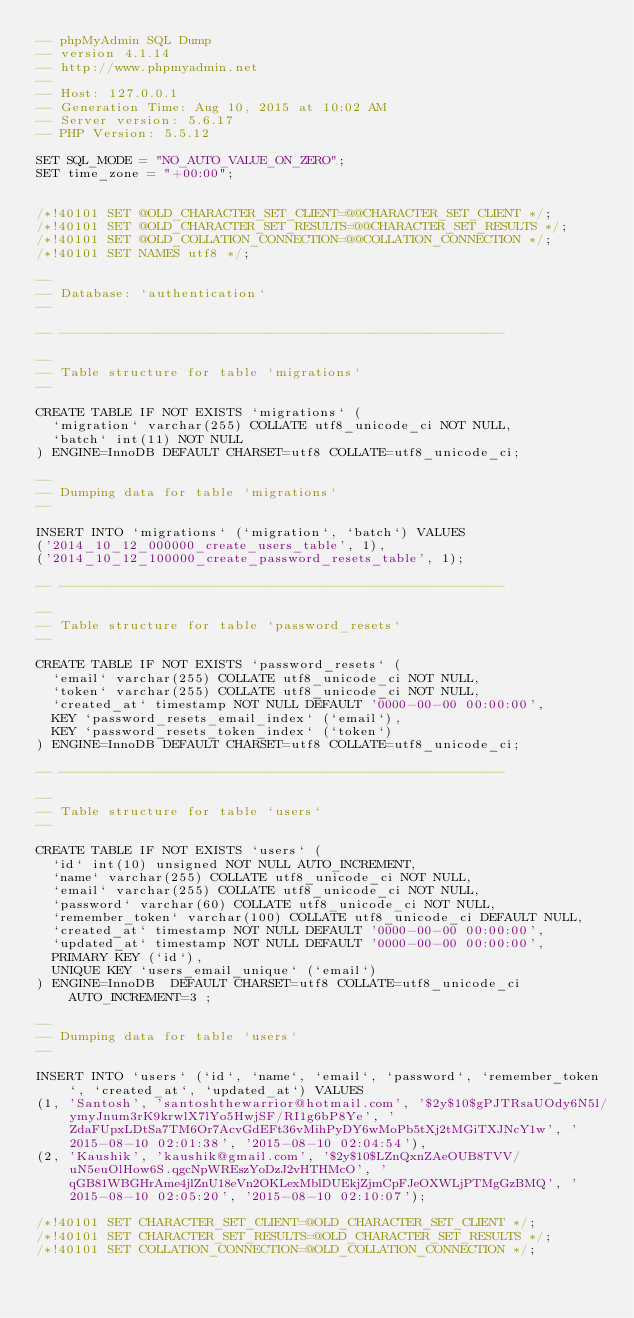Convert code to text. <code><loc_0><loc_0><loc_500><loc_500><_SQL_>-- phpMyAdmin SQL Dump
-- version 4.1.14
-- http://www.phpmyadmin.net
--
-- Host: 127.0.0.1
-- Generation Time: Aug 10, 2015 at 10:02 AM
-- Server version: 5.6.17
-- PHP Version: 5.5.12

SET SQL_MODE = "NO_AUTO_VALUE_ON_ZERO";
SET time_zone = "+00:00";


/*!40101 SET @OLD_CHARACTER_SET_CLIENT=@@CHARACTER_SET_CLIENT */;
/*!40101 SET @OLD_CHARACTER_SET_RESULTS=@@CHARACTER_SET_RESULTS */;
/*!40101 SET @OLD_COLLATION_CONNECTION=@@COLLATION_CONNECTION */;
/*!40101 SET NAMES utf8 */;

--
-- Database: `authentication`
--

-- --------------------------------------------------------

--
-- Table structure for table `migrations`
--

CREATE TABLE IF NOT EXISTS `migrations` (
  `migration` varchar(255) COLLATE utf8_unicode_ci NOT NULL,
  `batch` int(11) NOT NULL
) ENGINE=InnoDB DEFAULT CHARSET=utf8 COLLATE=utf8_unicode_ci;

--
-- Dumping data for table `migrations`
--

INSERT INTO `migrations` (`migration`, `batch`) VALUES
('2014_10_12_000000_create_users_table', 1),
('2014_10_12_100000_create_password_resets_table', 1);

-- --------------------------------------------------------

--
-- Table structure for table `password_resets`
--

CREATE TABLE IF NOT EXISTS `password_resets` (
  `email` varchar(255) COLLATE utf8_unicode_ci NOT NULL,
  `token` varchar(255) COLLATE utf8_unicode_ci NOT NULL,
  `created_at` timestamp NOT NULL DEFAULT '0000-00-00 00:00:00',
  KEY `password_resets_email_index` (`email`),
  KEY `password_resets_token_index` (`token`)
) ENGINE=InnoDB DEFAULT CHARSET=utf8 COLLATE=utf8_unicode_ci;

-- --------------------------------------------------------

--
-- Table structure for table `users`
--

CREATE TABLE IF NOT EXISTS `users` (
  `id` int(10) unsigned NOT NULL AUTO_INCREMENT,
  `name` varchar(255) COLLATE utf8_unicode_ci NOT NULL,
  `email` varchar(255) COLLATE utf8_unicode_ci NOT NULL,
  `password` varchar(60) COLLATE utf8_unicode_ci NOT NULL,
  `remember_token` varchar(100) COLLATE utf8_unicode_ci DEFAULT NULL,
  `created_at` timestamp NOT NULL DEFAULT '0000-00-00 00:00:00',
  `updated_at` timestamp NOT NULL DEFAULT '0000-00-00 00:00:00',
  PRIMARY KEY (`id`),
  UNIQUE KEY `users_email_unique` (`email`)
) ENGINE=InnoDB  DEFAULT CHARSET=utf8 COLLATE=utf8_unicode_ci AUTO_INCREMENT=3 ;

--
-- Dumping data for table `users`
--

INSERT INTO `users` (`id`, `name`, `email`, `password`, `remember_token`, `created_at`, `updated_at`) VALUES
(1, 'Santosh', 'santoshthewarrior@hotmail.com', '$2y$10$gPJTRsaUOdy6N5l/ymyJnum3rK9krwlX7lYo5HwjSF/RI1g6bP8Ye', 'ZdaFUpxLDtSa7TM6Or7AcvGdEFt36vMihPyDY6wMoPb5tXj2tMGiTXJNcY1w', '2015-08-10 02:01:38', '2015-08-10 02:04:54'),
(2, 'Kaushik', 'kaushik@gmail.com', '$2y$10$LZnQxnZAeOUB8TVV/uN5euOlHow6S.qgcNpWREszYoDzJ2vHTHMcO', 'qGB81WBGHrAme4jlZnU18eVn2OKLexMblDUEkjZjmCpFJeOXWLjPTMgGzBMQ', '2015-08-10 02:05:20', '2015-08-10 02:10:07');

/*!40101 SET CHARACTER_SET_CLIENT=@OLD_CHARACTER_SET_CLIENT */;
/*!40101 SET CHARACTER_SET_RESULTS=@OLD_CHARACTER_SET_RESULTS */;
/*!40101 SET COLLATION_CONNECTION=@OLD_COLLATION_CONNECTION */;
</code> 